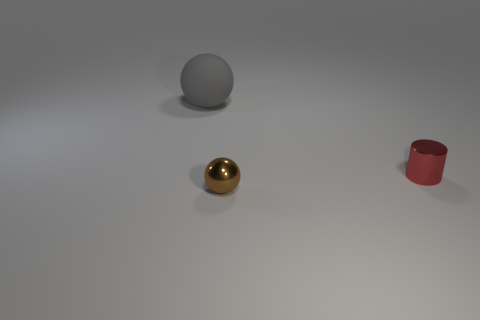There is a sphere that is behind the brown object; is its size the same as the tiny metallic ball?
Your answer should be very brief. No. Are there any matte balls of the same color as the big matte thing?
Make the answer very short. No. There is a red object that is made of the same material as the small sphere; what is its size?
Your answer should be compact. Small. Are there more tiny metallic cylinders that are behind the red object than gray rubber spheres that are in front of the gray matte thing?
Provide a short and direct response. No. How many other things are there of the same material as the tiny brown sphere?
Provide a short and direct response. 1. Is the thing that is on the left side of the small brown shiny sphere made of the same material as the tiny brown sphere?
Ensure brevity in your answer.  No. The small red object has what shape?
Your response must be concise. Cylinder. Is the number of small red cylinders right of the small cylinder greater than the number of small metal cylinders?
Your response must be concise. No. Is there any other thing that has the same shape as the large gray matte object?
Offer a terse response. Yes. What is the color of the other tiny object that is the same shape as the gray object?
Make the answer very short. Brown. 